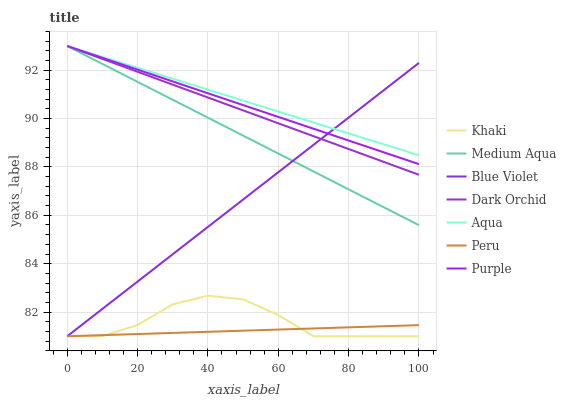Does Peru have the minimum area under the curve?
Answer yes or no. Yes. Does Aqua have the maximum area under the curve?
Answer yes or no. Yes. Does Purple have the minimum area under the curve?
Answer yes or no. No. Does Purple have the maximum area under the curve?
Answer yes or no. No. Is Blue Violet the smoothest?
Answer yes or no. Yes. Is Khaki the roughest?
Answer yes or no. Yes. Is Purple the smoothest?
Answer yes or no. No. Is Purple the roughest?
Answer yes or no. No. Does Khaki have the lowest value?
Answer yes or no. Yes. Does Purple have the lowest value?
Answer yes or no. No. Does Medium Aqua have the highest value?
Answer yes or no. Yes. Does Peru have the highest value?
Answer yes or no. No. Is Khaki less than Dark Orchid?
Answer yes or no. Yes. Is Medium Aqua greater than Khaki?
Answer yes or no. Yes. Does Aqua intersect Blue Violet?
Answer yes or no. Yes. Is Aqua less than Blue Violet?
Answer yes or no. No. Is Aqua greater than Blue Violet?
Answer yes or no. No. Does Khaki intersect Dark Orchid?
Answer yes or no. No. 